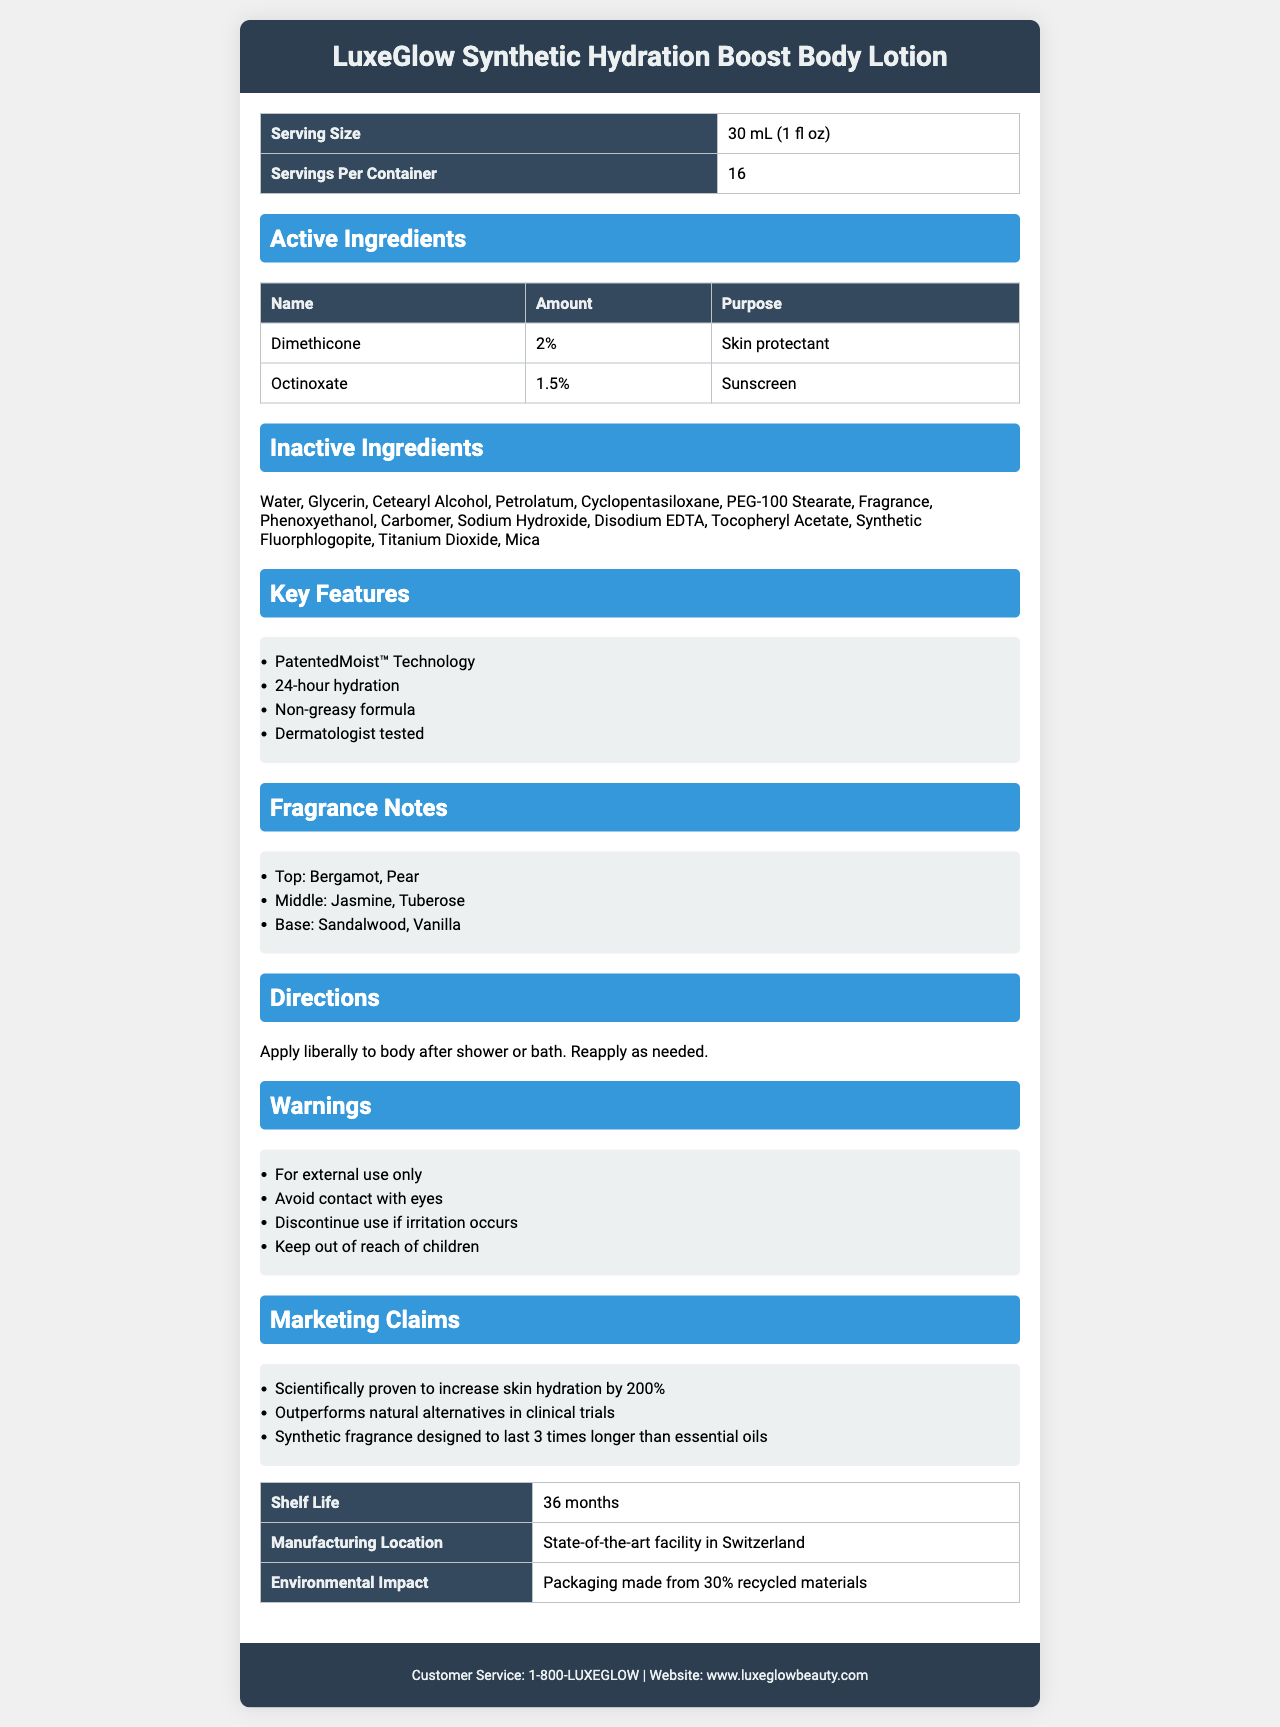who is the target audience for the LuxeGlow Synthetic Hydration Boost Body Lotion? The document highlights attributes such as patented moisturizing technology, synthetic fragrance, and dermatologist testing, which suggest it is geared towards consumers interested in high-end synthetic beauty products.
Answer: People looking for premium synthetic body lotions what are the active ingredients listed in the LuxeGlow lotion? The active ingredients section of the document lists Dimethicone (2%) and Octinoxate (1.5%).
Answer: Dimethicone and Octinoxate what is the primary function of Dimethicone in this lotion? The document specifies that Dimethicone’s purpose is to act as a skin protectant.
Answer: Skin protectant what are the fragrance notes of the lotion? The fragrance notes section lists these blends for top, middle, and base notes.
Answer: Top: Bergamot, Pear; Middle: Jasmine, Tuberose; Base: Sandalwood, Vanilla how many servings are there per container of the body lotion? The table under Serving Size and Servings Per Container indicates that there are 16 servings per container.
Answer: 16 what does the PatentedMoist™ Technology claim to provide? The key features section includes PatentedMoist™ Technology and 24-hour hydration.
Answer: 24-hour hydration list one possible reason someone might stop using the lotion One of the warnings advises discontinuation if irritation occurs.
Answer: Discontinue use if irritation occurs how long does the synthetic fragrance claim to last compared to essential oils? The marketing claims section states that the synthetic fragrance is designed to last 3 times longer than essential oils.
Answer: 3 times longer which statement is true regarding the environmental impact of the lotion's packaging?
1. Packaging made from 30% recycled materials
2. Packaging is fully biodegradable
3. Packaging contains no recycled materials
4. Packaging is made from 100% recycled materials The document states the packaging is made from 30% recycled materials.
Answer: 1. Packaging made from 30% recycled materials which feature is not a key benefit of the lotion?
A. 24-hour hydration
B. Anti-aging properties
C. Non-greasy formula
D. Dermatologist tested The key features do not mention anti-aging properties but do list 24-hour hydration, non-greasy formula, and dermatologist-tested.
Answer: B. Anti-aging properties is the LuxeGlow lotion based on natural ingredients? The marketing claims highlight that the product outperforms natural alternatives and uses synthetic ingredients.
Answer: No summarize the main idea of the LuxeGlow Synthetic Hydration Boost Body Lotion's nutrition facts label The document provides detailed information on the product's active and inactive ingredients, key features, fragrance notes, directions, warnings, marketing claims, and other relevant information to showcase its benefits and usage.
Answer: LuxeGlow Synthetic Hydration Boost Body Lotion is a premium synthetic body lotion with patented moisturizing technology, designed for long-lasting hydration and enhanced by a synthetic fragrance. It includes active ingredients like Dimethicone and Octinoxate, offers a variety of skin benefits, and comes with specific directions and warnings. what is the precise percentage of synthetic ingredients used in the lotion? The document lists various synthetic ingredients but does not provide a precise percentage for all components together, so the total percentage of synthetic ingredients cannot be determined.
Answer: Not enough information 